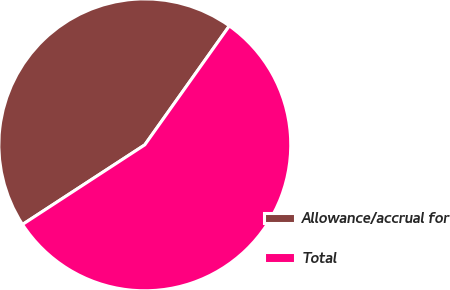Convert chart. <chart><loc_0><loc_0><loc_500><loc_500><pie_chart><fcel>Allowance/accrual for<fcel>Total<nl><fcel>44.02%<fcel>55.98%<nl></chart> 